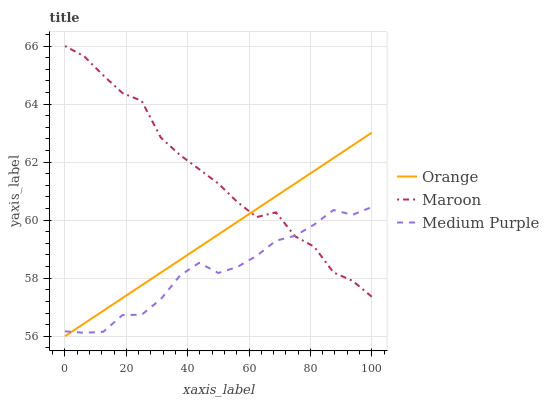Does Medium Purple have the minimum area under the curve?
Answer yes or no. Yes. Does Maroon have the maximum area under the curve?
Answer yes or no. Yes. Does Maroon have the minimum area under the curve?
Answer yes or no. No. Does Medium Purple have the maximum area under the curve?
Answer yes or no. No. Is Orange the smoothest?
Answer yes or no. Yes. Is Maroon the roughest?
Answer yes or no. Yes. Is Medium Purple the smoothest?
Answer yes or no. No. Is Medium Purple the roughest?
Answer yes or no. No. Does Orange have the lowest value?
Answer yes or no. Yes. Does Medium Purple have the lowest value?
Answer yes or no. No. Does Maroon have the highest value?
Answer yes or no. Yes. Does Medium Purple have the highest value?
Answer yes or no. No. Does Maroon intersect Medium Purple?
Answer yes or no. Yes. Is Maroon less than Medium Purple?
Answer yes or no. No. Is Maroon greater than Medium Purple?
Answer yes or no. No. 